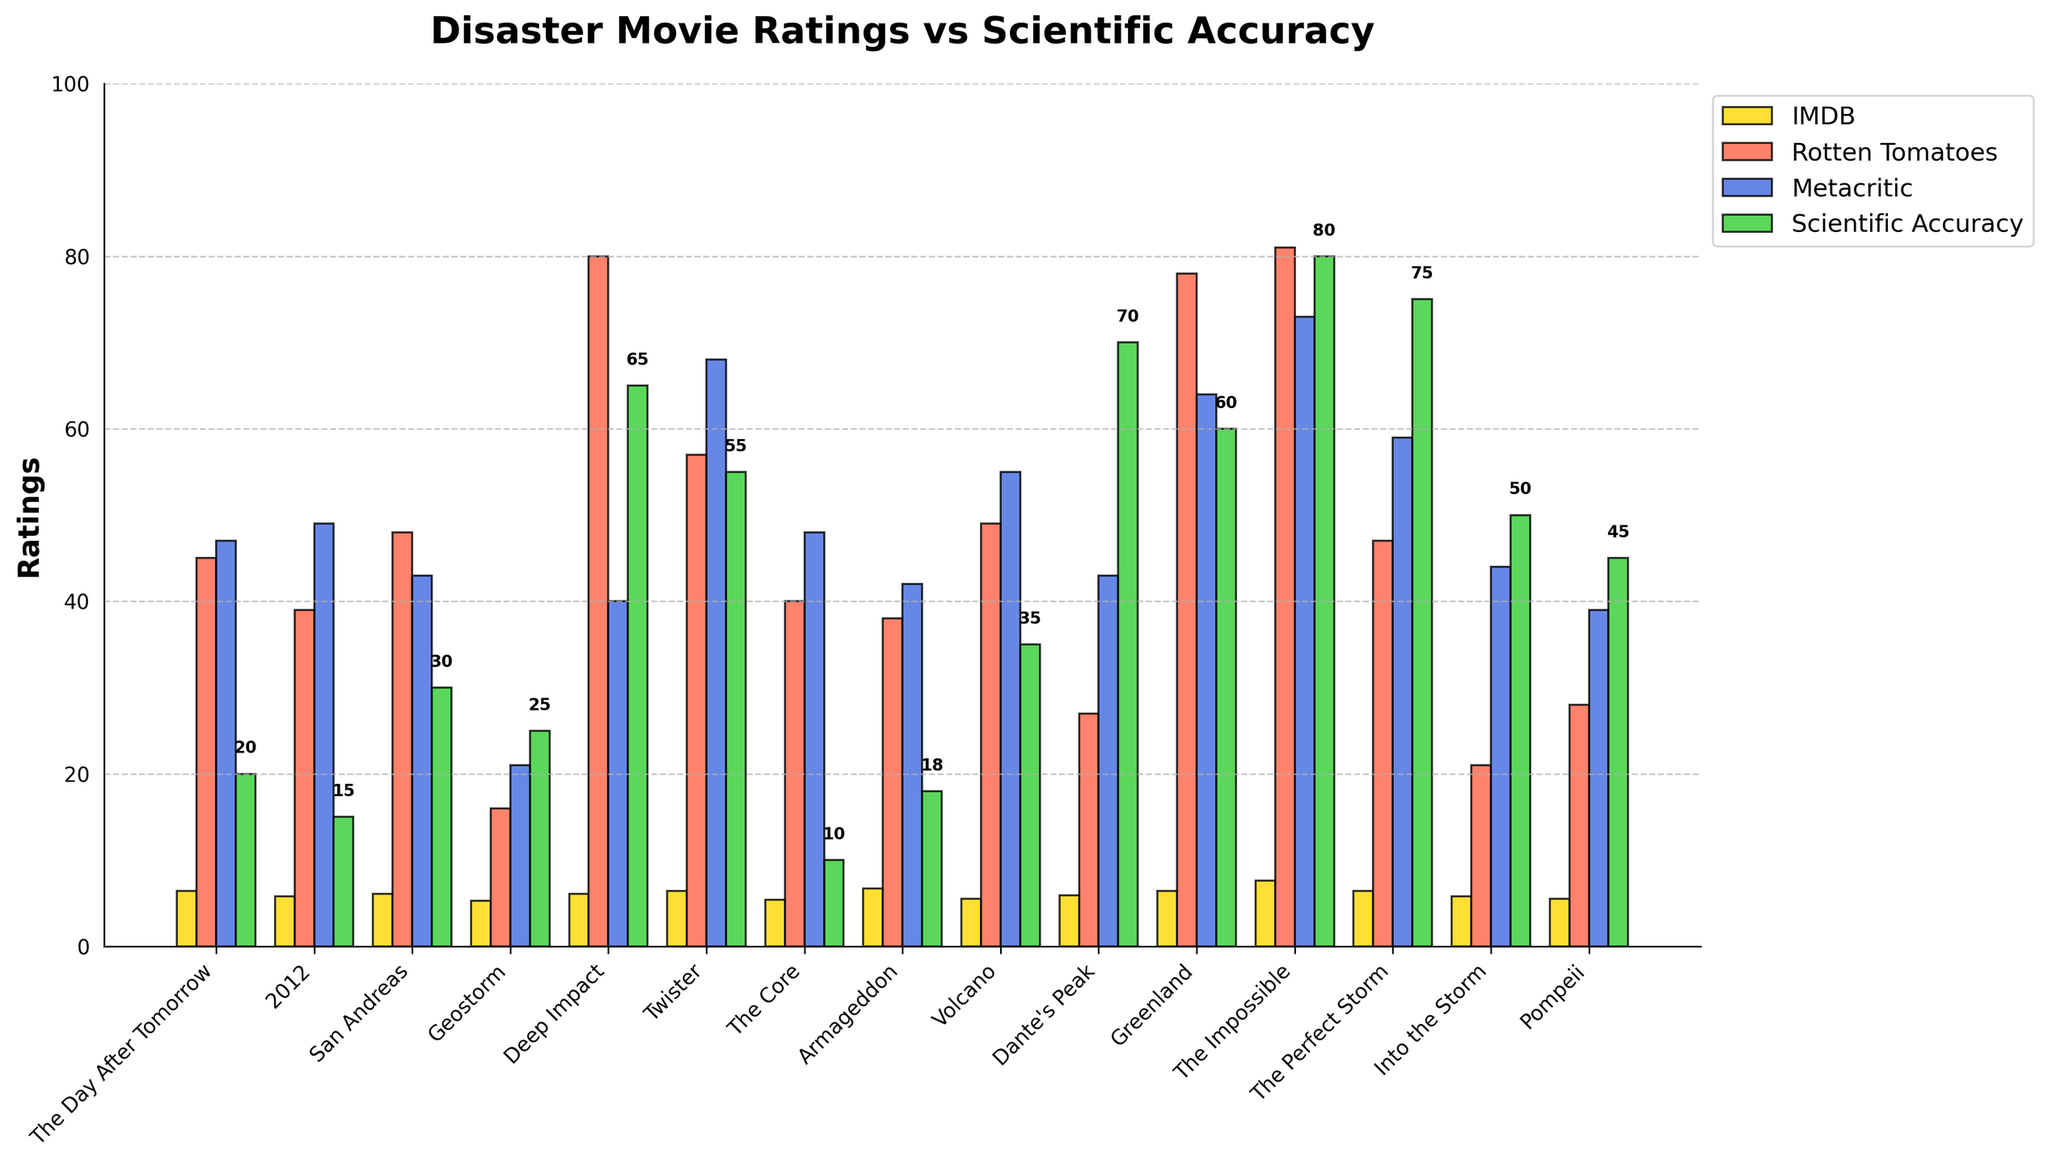What's the highest rating given by Rotten Tomatoes? Looking at the bar heights for each movie under Rotten Tomatoes (red bars), the highest bar corresponds to "The Impossible" with a rating of 81.
Answer: 81 Which movie has the lowest scientific accuracy score? Checking the heights of the green bars for scientific accuracy, "The Core" has the lowest bar with a score of 10.
Answer: The Core What's the average Metacritic score for all the movies? Sum the Metacritic scores provided (47 + 49 + 43 + 21 + 40 + 68 + 48 + 42 + 55 + 43 + 64 + 73 + 59 + 44 + 39 = 635). With 15 movies, the average is 635/15 = 42.33.
Answer: 42.33 Which movie has the most consistent ratings across all platforms, taking the smallest difference between highest and lowest ratings? Calculate the differences for each movie and find the smallest: 
- The Impossible: 81 - 73 = 8
- Greenland: 78 - 60 = 18
- Deep Impact: 80 - 40 = 40
- Twister: 68 - 55 = 13
"The Impossible" has the smallest difference with 8.
Answer: The Impossible Which movie received a higher scientific accuracy score than its Metacritic score? Compare each movie's scientific accuracy and Metacritic scores. "The Perfect Storm" has a scientific accuracy of 75, which is higher than its Metacritic score of 59.
Answer: The Perfect Storm Which movie has the highest difference between its IMDB rating and scientific accuracy score? Calculate the differences for each movie and find the highest:
- The Core: 5.4 - 10 = -4.6
- Dante's Peak: 5.9 - 70 = -64.1
"Deep Impact" has the highest difference between the IMDB rating (6.1) and scientific accuracy score (65), with a difference of 58.9.
Answer: Deep Impact What's the total sum of all Rotten Tomatoes scores for the movies? Adding up the Rotten Tomatoes scores provided (45 + 39 + 48 + 16 + 80 + 57 + 40 + 38 + 49 + 27 + 78 + 81 + 47 + 21 + 28 = 694). The total sum is 694.
Answer: 694 Which movie has a higher Rotten Tomatoes rating but a lower IMDB rating than "The Core"? "The Core" has an IMDB rating of 5.4 and a Rotten Tomatoes rating of 40. "Deep Impact" (80), "Greenland" (78), and "The Impossible" (81) have higher Rotten Tomatoes ratings. "Deep Impact" (6.1), "Greenland" (6.4), and "The Impossible" (7.6) all have higher IMDB ratings, none match the Rotten Tomatoes high/IMDB low pattern.
Answer: None What's the movie with the highest difference between Rotten Tomatoes rating and scientific accuracy score? Calculate the differences for each movie and find the highest:
- The Core: 40 - 10 = 30
- Geostorm: 16 - 25 = -9
"Dante's Peak" has the highest difference between Rotten Tomatoes rating (27) and scientific accuracy (70), with a difference of 43.
Answer: Dante's Peak 